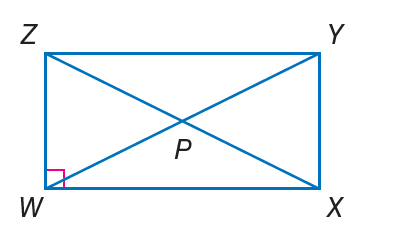Answer the mathemtical geometry problem and directly provide the correct option letter.
Question: If m \angle Z Y W = 2 x - 7 and m \angle W Y X = 2 x + 5, find m \angle Z Y W.
Choices: A: 13 B: 23 C: 39 D: 46 C 